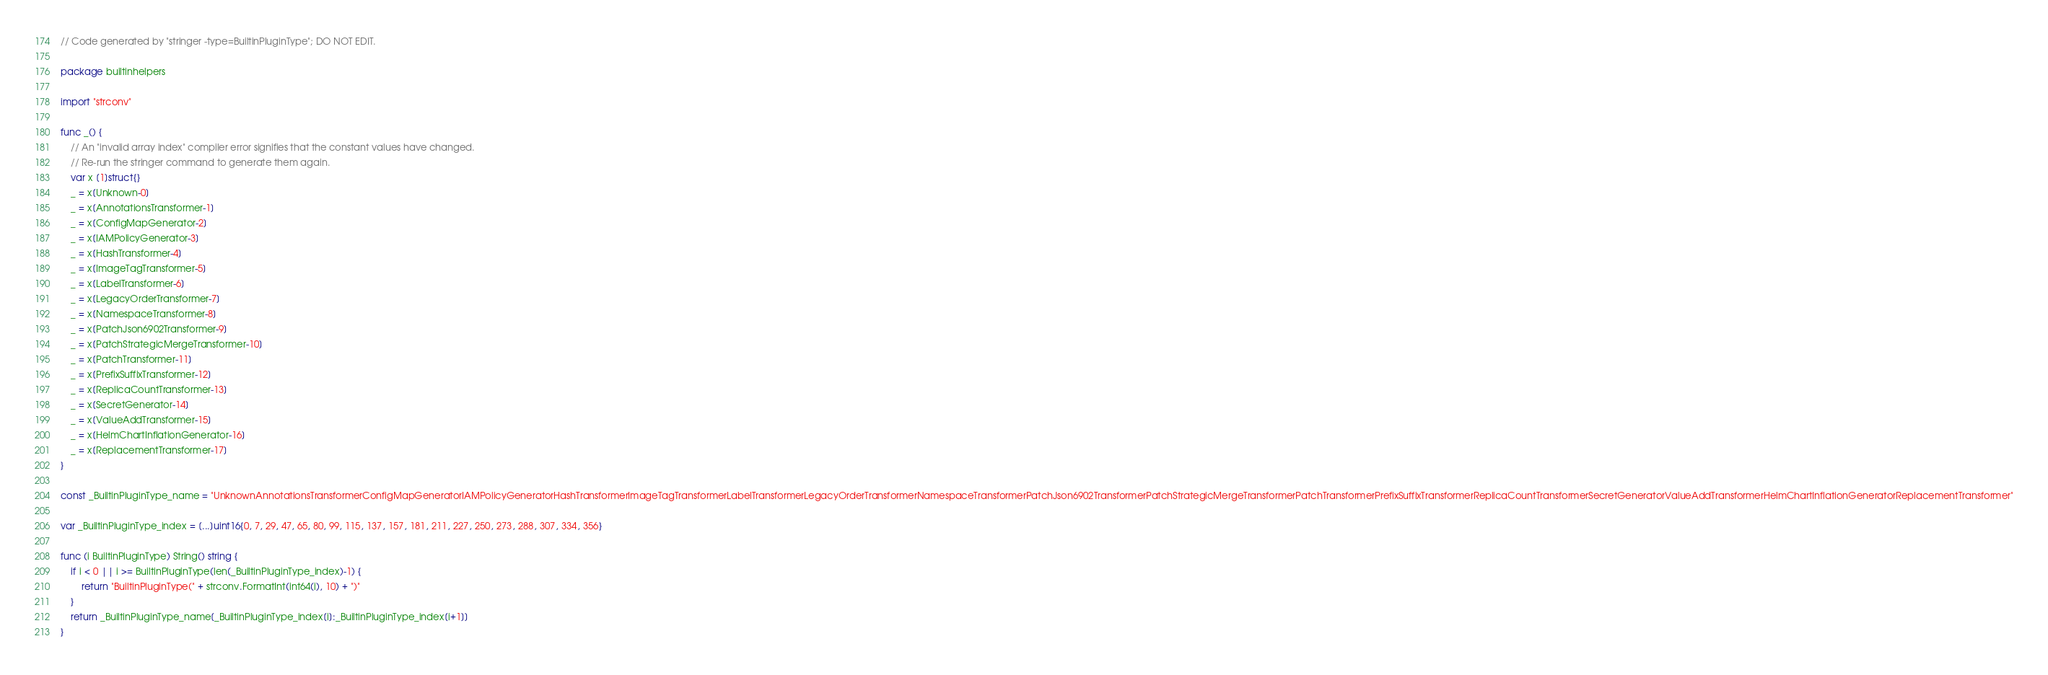Convert code to text. <code><loc_0><loc_0><loc_500><loc_500><_Go_>// Code generated by "stringer -type=BuiltinPluginType"; DO NOT EDIT.

package builtinhelpers

import "strconv"

func _() {
	// An "invalid array index" compiler error signifies that the constant values have changed.
	// Re-run the stringer command to generate them again.
	var x [1]struct{}
	_ = x[Unknown-0]
	_ = x[AnnotationsTransformer-1]
	_ = x[ConfigMapGenerator-2]
	_ = x[IAMPolicyGenerator-3]
	_ = x[HashTransformer-4]
	_ = x[ImageTagTransformer-5]
	_ = x[LabelTransformer-6]
	_ = x[LegacyOrderTransformer-7]
	_ = x[NamespaceTransformer-8]
	_ = x[PatchJson6902Transformer-9]
	_ = x[PatchStrategicMergeTransformer-10]
	_ = x[PatchTransformer-11]
	_ = x[PrefixSuffixTransformer-12]
	_ = x[ReplicaCountTransformer-13]
	_ = x[SecretGenerator-14]
	_ = x[ValueAddTransformer-15]
	_ = x[HelmChartInflationGenerator-16]
	_ = x[ReplacementTransformer-17]
}

const _BuiltinPluginType_name = "UnknownAnnotationsTransformerConfigMapGeneratorIAMPolicyGeneratorHashTransformerImageTagTransformerLabelTransformerLegacyOrderTransformerNamespaceTransformerPatchJson6902TransformerPatchStrategicMergeTransformerPatchTransformerPrefixSuffixTransformerReplicaCountTransformerSecretGeneratorValueAddTransformerHelmChartInflationGeneratorReplacementTransformer"

var _BuiltinPluginType_index = [...]uint16{0, 7, 29, 47, 65, 80, 99, 115, 137, 157, 181, 211, 227, 250, 273, 288, 307, 334, 356}

func (i BuiltinPluginType) String() string {
	if i < 0 || i >= BuiltinPluginType(len(_BuiltinPluginType_index)-1) {
		return "BuiltinPluginType(" + strconv.FormatInt(int64(i), 10) + ")"
	}
	return _BuiltinPluginType_name[_BuiltinPluginType_index[i]:_BuiltinPluginType_index[i+1]]
}
</code> 